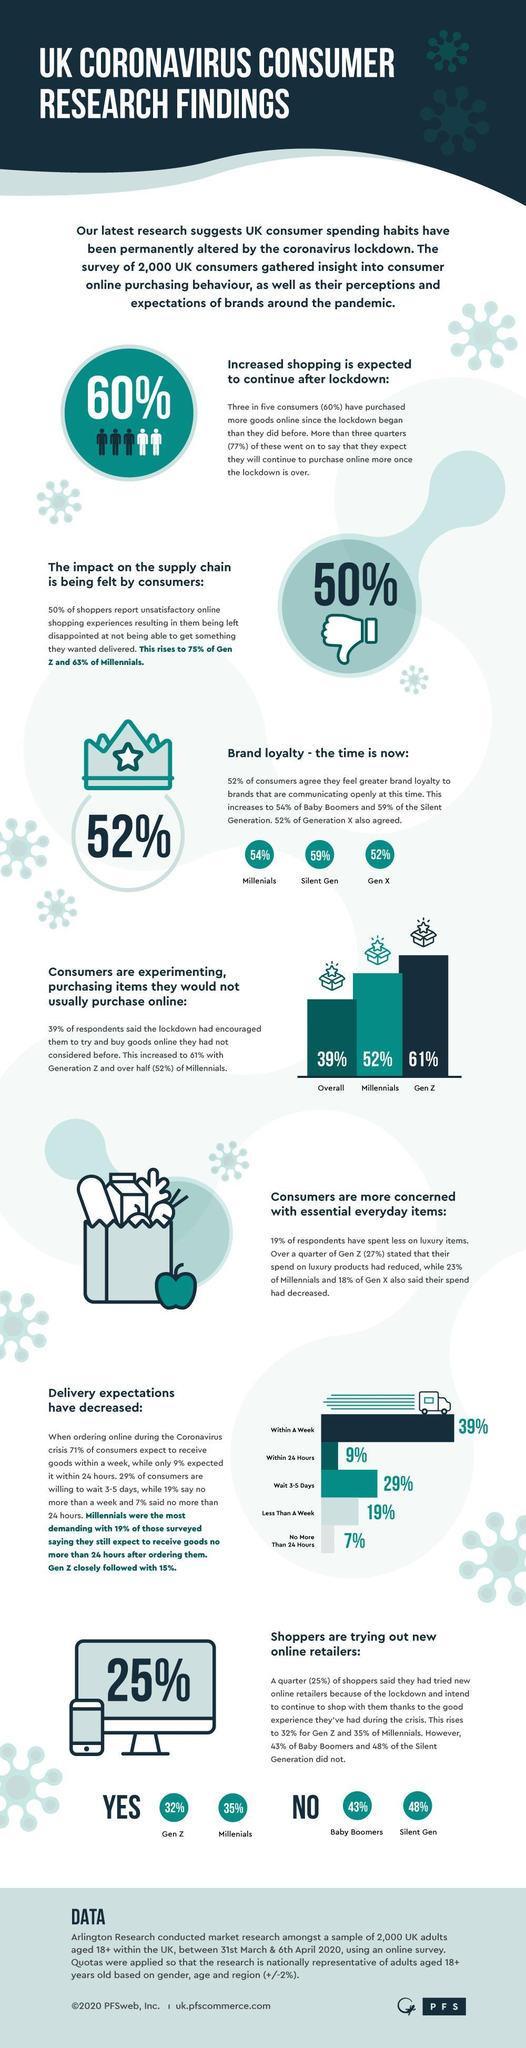what is the difference in percentage of shoppers who are trying out new online retailers from gen z and millennials??
Answer the question with a short phrase. 3% Which age group is more concerned about reducing spending on luxury items? generation z Who is more likely to try new things while shopping online - millennials or generation z? generation z Who is the most demanding generation after millennials? gen z What percent of generation z are trying new things in online shopping? 61% who feels more loyal towards the brands who communicate openly - millennials or silent generation? silent generation what is the difference in percentage of reduced spending on luxury items by generation z and generation x? 9% what is the difference in percentage of reduced spending on luxury items by generation z and millennials? 4% What is the increase in percentage from overall consumers when it comes to millennials in trying new things while shopping online? 13 Shoppers from which generations are not trying out new online retailers? baby boomers, silent generation 